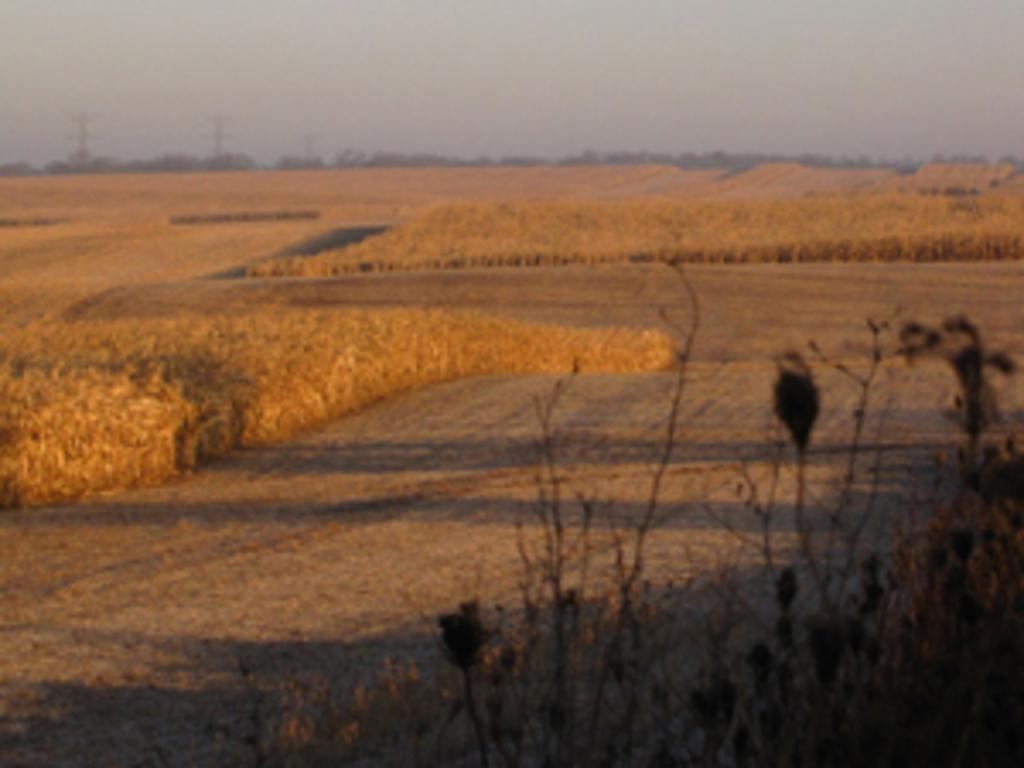What type of environment is shown in the image? The image depicts a dried land. Are there any living organisms visible in the dried land? Yes, there are plants present in the dried land. What can be seen in the sky in the image? The sky is visible in the image. How would you describe the sky's appearance in the image? The sky appears to be cloudy. What type of vacation is being advertised in the image? There is no vacation being advertised in the image; it depicts a dried land with plants and a cloudy sky. What educational institution is shown in the image? There is no educational institution present in the image; it depicts a dried land with plants and a cloudy sky. 